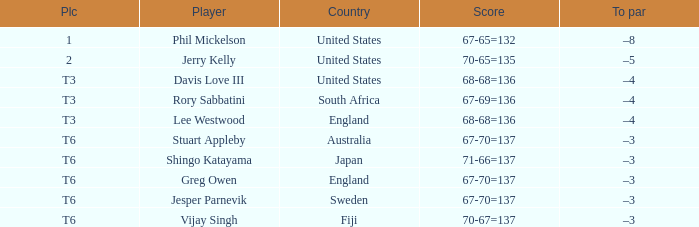Name the player for fiji Vijay Singh. 